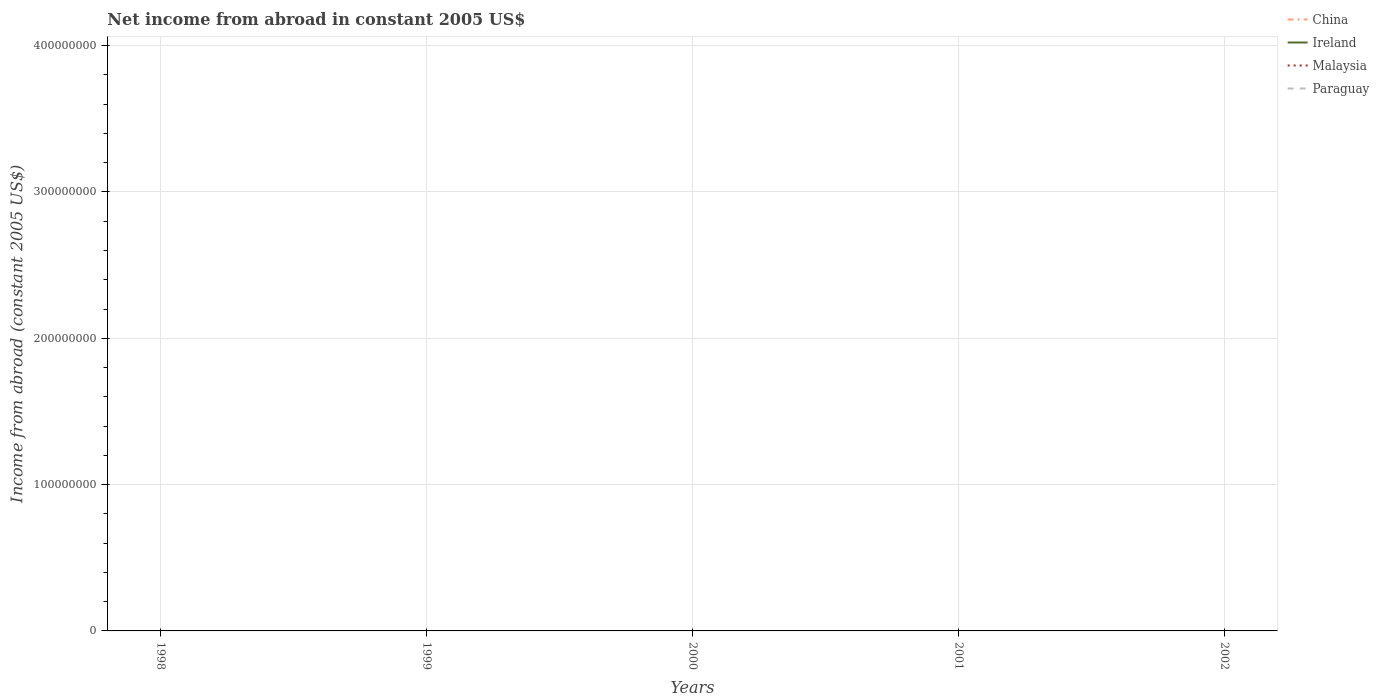Is the number of lines equal to the number of legend labels?
Your response must be concise. No. What is the difference between the highest and the lowest net income from abroad in Paraguay?
Make the answer very short. 0. Is the net income from abroad in Malaysia strictly greater than the net income from abroad in Ireland over the years?
Offer a very short reply. No. How many lines are there?
Your response must be concise. 0. Does the graph contain grids?
Your response must be concise. Yes. How many legend labels are there?
Provide a succinct answer. 4. What is the title of the graph?
Ensure brevity in your answer.  Net income from abroad in constant 2005 US$. What is the label or title of the Y-axis?
Your answer should be compact. Income from abroad (constant 2005 US$). What is the Income from abroad (constant 2005 US$) in Ireland in 1998?
Your response must be concise. 0. What is the Income from abroad (constant 2005 US$) in Malaysia in 1998?
Keep it short and to the point. 0. What is the Income from abroad (constant 2005 US$) in Paraguay in 1998?
Offer a terse response. 0. What is the Income from abroad (constant 2005 US$) of China in 1999?
Your response must be concise. 0. What is the Income from abroad (constant 2005 US$) of Ireland in 1999?
Provide a succinct answer. 0. What is the Income from abroad (constant 2005 US$) in China in 2000?
Ensure brevity in your answer.  0. What is the Income from abroad (constant 2005 US$) in Paraguay in 2000?
Provide a short and direct response. 0. What is the Income from abroad (constant 2005 US$) of Malaysia in 2001?
Your answer should be very brief. 0. What is the Income from abroad (constant 2005 US$) in China in 2002?
Provide a succinct answer. 0. What is the Income from abroad (constant 2005 US$) of Ireland in 2002?
Provide a succinct answer. 0. What is the Income from abroad (constant 2005 US$) in Malaysia in 2002?
Make the answer very short. 0. What is the total Income from abroad (constant 2005 US$) in Ireland in the graph?
Offer a terse response. 0. What is the total Income from abroad (constant 2005 US$) in Paraguay in the graph?
Your answer should be very brief. 0. What is the average Income from abroad (constant 2005 US$) in China per year?
Your response must be concise. 0. What is the average Income from abroad (constant 2005 US$) in Ireland per year?
Your response must be concise. 0. What is the average Income from abroad (constant 2005 US$) of Malaysia per year?
Give a very brief answer. 0. What is the average Income from abroad (constant 2005 US$) of Paraguay per year?
Your response must be concise. 0. 